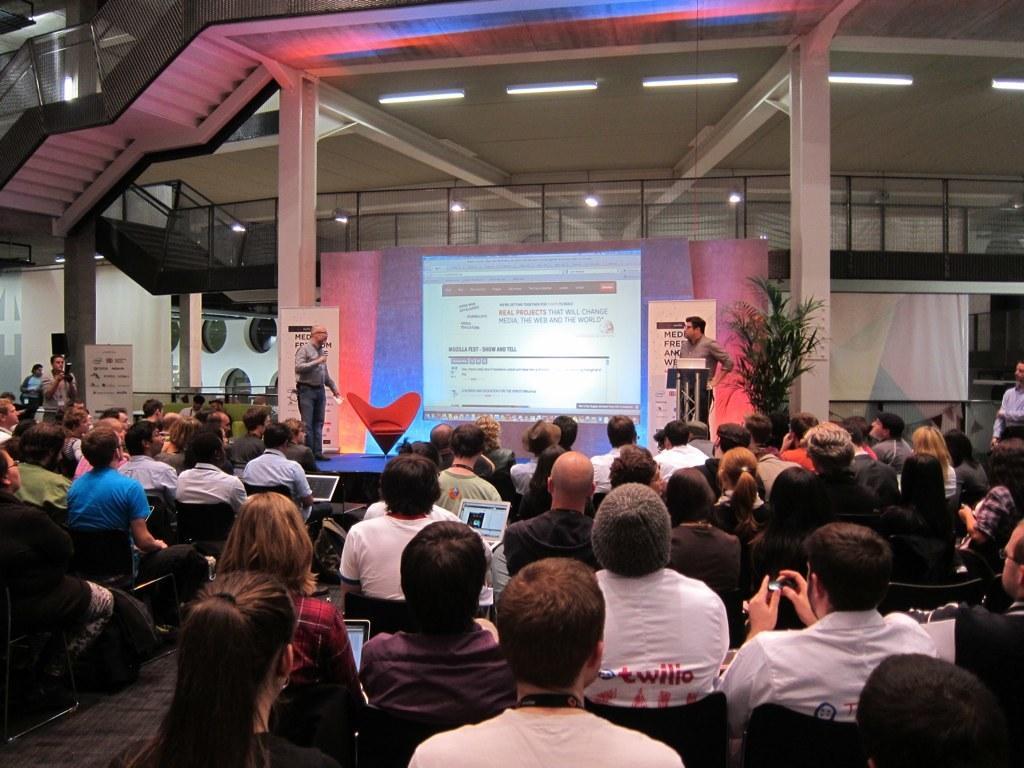Could you give a brief overview of what you see in this image? In this image at the bottom there is a man, he wears a t shirt and there is a woman. In the middle there are some people, they are sitting. On the right there is a man, he wears a shirt, trouser, in front of him there is a podium. On the left there is a man, he wears a shirt, trouser, he is on the stage. On the left there is a man, he wears a t shirt, he is holding a camera 